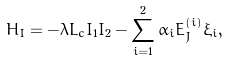<formula> <loc_0><loc_0><loc_500><loc_500>H _ { I } = - \lambda L _ { c } I _ { 1 } I _ { 2 } - \sum _ { i = 1 } ^ { 2 } \alpha _ { i } E _ { J } ^ { ( i ) } \xi _ { i } ,</formula> 